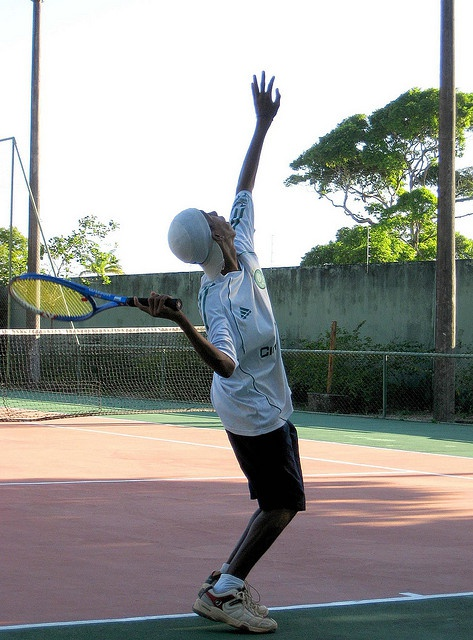Describe the objects in this image and their specific colors. I can see people in white, black, and gray tones and tennis racket in white, olive, black, gray, and navy tones in this image. 